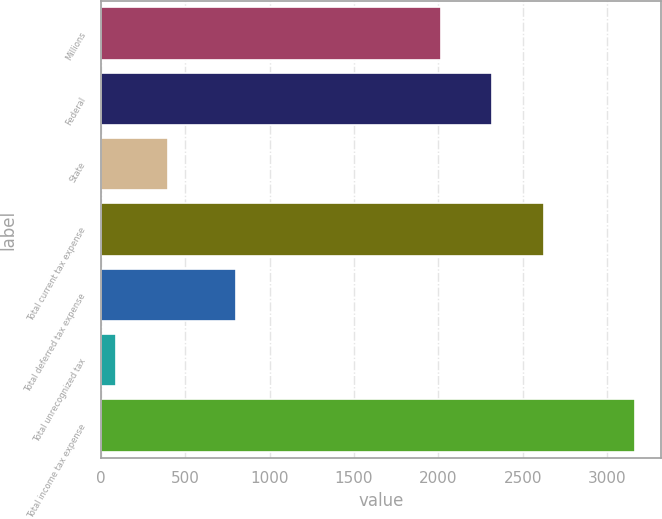Convert chart. <chart><loc_0><loc_0><loc_500><loc_500><bar_chart><fcel>Millions<fcel>Federal<fcel>State<fcel>Total current tax expense<fcel>Total deferred tax expense<fcel>Total unrecognized tax<fcel>Total income tax expense<nl><fcel>2014<fcel>2321.1<fcel>399.1<fcel>2628.2<fcel>803<fcel>92<fcel>3163<nl></chart> 